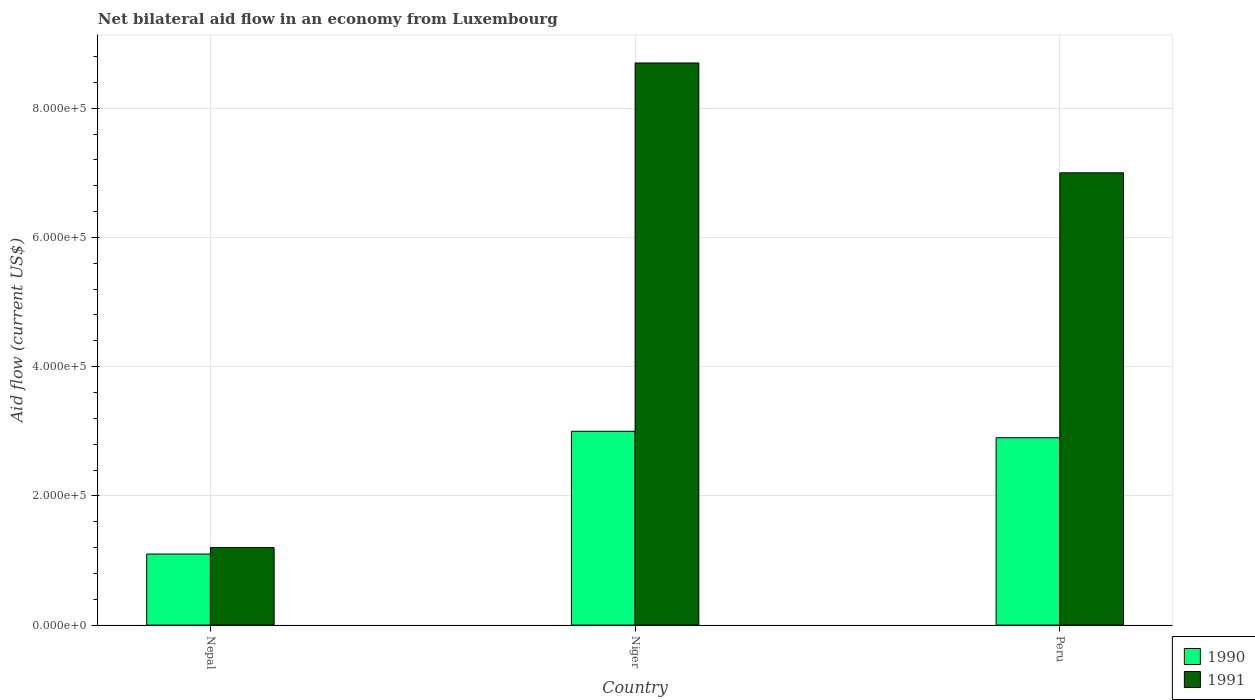How many groups of bars are there?
Offer a terse response. 3. Are the number of bars per tick equal to the number of legend labels?
Your answer should be compact. Yes. How many bars are there on the 2nd tick from the right?
Give a very brief answer. 2. What is the label of the 1st group of bars from the left?
Ensure brevity in your answer.  Nepal. In how many cases, is the number of bars for a given country not equal to the number of legend labels?
Provide a short and direct response. 0. What is the net bilateral aid flow in 1990 in Niger?
Ensure brevity in your answer.  3.00e+05. Across all countries, what is the maximum net bilateral aid flow in 1991?
Provide a short and direct response. 8.70e+05. Across all countries, what is the minimum net bilateral aid flow in 1991?
Give a very brief answer. 1.20e+05. In which country was the net bilateral aid flow in 1991 maximum?
Your answer should be compact. Niger. In which country was the net bilateral aid flow in 1990 minimum?
Provide a succinct answer. Nepal. What is the total net bilateral aid flow in 1991 in the graph?
Ensure brevity in your answer.  1.69e+06. What is the difference between the net bilateral aid flow in 1991 in Nepal and that in Niger?
Your response must be concise. -7.50e+05. What is the difference between the net bilateral aid flow in 1990 in Niger and the net bilateral aid flow in 1991 in Peru?
Offer a terse response. -4.00e+05. What is the average net bilateral aid flow in 1991 per country?
Ensure brevity in your answer.  5.63e+05. What is the difference between the net bilateral aid flow of/in 1991 and net bilateral aid flow of/in 1990 in Nepal?
Provide a short and direct response. 10000. In how many countries, is the net bilateral aid flow in 1991 greater than 440000 US$?
Ensure brevity in your answer.  2. What is the ratio of the net bilateral aid flow in 1990 in Nepal to that in Niger?
Keep it short and to the point. 0.37. Is the net bilateral aid flow in 1990 in Nepal less than that in Peru?
Your answer should be very brief. Yes. What is the difference between the highest and the second highest net bilateral aid flow in 1991?
Your answer should be compact. 1.70e+05. What is the difference between the highest and the lowest net bilateral aid flow in 1991?
Offer a very short reply. 7.50e+05. In how many countries, is the net bilateral aid flow in 1990 greater than the average net bilateral aid flow in 1990 taken over all countries?
Offer a terse response. 2. Is the sum of the net bilateral aid flow in 1991 in Nepal and Niger greater than the maximum net bilateral aid flow in 1990 across all countries?
Provide a succinct answer. Yes. What does the 1st bar from the left in Niger represents?
Offer a terse response. 1990. What does the 1st bar from the right in Nepal represents?
Provide a succinct answer. 1991. Are all the bars in the graph horizontal?
Your answer should be very brief. No. Are the values on the major ticks of Y-axis written in scientific E-notation?
Give a very brief answer. Yes. Does the graph contain any zero values?
Keep it short and to the point. No. Does the graph contain grids?
Give a very brief answer. Yes. How many legend labels are there?
Your answer should be compact. 2. What is the title of the graph?
Provide a short and direct response. Net bilateral aid flow in an economy from Luxembourg. Does "1983" appear as one of the legend labels in the graph?
Provide a short and direct response. No. What is the label or title of the X-axis?
Ensure brevity in your answer.  Country. What is the Aid flow (current US$) of 1991 in Nepal?
Give a very brief answer. 1.20e+05. What is the Aid flow (current US$) of 1990 in Niger?
Your answer should be very brief. 3.00e+05. What is the Aid flow (current US$) of 1991 in Niger?
Give a very brief answer. 8.70e+05. What is the Aid flow (current US$) in 1991 in Peru?
Offer a terse response. 7.00e+05. Across all countries, what is the maximum Aid flow (current US$) in 1991?
Provide a succinct answer. 8.70e+05. Across all countries, what is the minimum Aid flow (current US$) in 1991?
Keep it short and to the point. 1.20e+05. What is the total Aid flow (current US$) in 1991 in the graph?
Keep it short and to the point. 1.69e+06. What is the difference between the Aid flow (current US$) in 1991 in Nepal and that in Niger?
Offer a very short reply. -7.50e+05. What is the difference between the Aid flow (current US$) in 1990 in Nepal and that in Peru?
Your answer should be very brief. -1.80e+05. What is the difference between the Aid flow (current US$) of 1991 in Nepal and that in Peru?
Keep it short and to the point. -5.80e+05. What is the difference between the Aid flow (current US$) in 1990 in Niger and that in Peru?
Make the answer very short. 10000. What is the difference between the Aid flow (current US$) of 1991 in Niger and that in Peru?
Your answer should be very brief. 1.70e+05. What is the difference between the Aid flow (current US$) in 1990 in Nepal and the Aid flow (current US$) in 1991 in Niger?
Ensure brevity in your answer.  -7.60e+05. What is the difference between the Aid flow (current US$) in 1990 in Nepal and the Aid flow (current US$) in 1991 in Peru?
Keep it short and to the point. -5.90e+05. What is the difference between the Aid flow (current US$) of 1990 in Niger and the Aid flow (current US$) of 1991 in Peru?
Give a very brief answer. -4.00e+05. What is the average Aid flow (current US$) in 1990 per country?
Give a very brief answer. 2.33e+05. What is the average Aid flow (current US$) in 1991 per country?
Provide a short and direct response. 5.63e+05. What is the difference between the Aid flow (current US$) of 1990 and Aid flow (current US$) of 1991 in Nepal?
Offer a very short reply. -10000. What is the difference between the Aid flow (current US$) in 1990 and Aid flow (current US$) in 1991 in Niger?
Your response must be concise. -5.70e+05. What is the difference between the Aid flow (current US$) in 1990 and Aid flow (current US$) in 1991 in Peru?
Give a very brief answer. -4.10e+05. What is the ratio of the Aid flow (current US$) of 1990 in Nepal to that in Niger?
Your answer should be very brief. 0.37. What is the ratio of the Aid flow (current US$) in 1991 in Nepal to that in Niger?
Make the answer very short. 0.14. What is the ratio of the Aid flow (current US$) in 1990 in Nepal to that in Peru?
Make the answer very short. 0.38. What is the ratio of the Aid flow (current US$) in 1991 in Nepal to that in Peru?
Provide a short and direct response. 0.17. What is the ratio of the Aid flow (current US$) in 1990 in Niger to that in Peru?
Offer a very short reply. 1.03. What is the ratio of the Aid flow (current US$) in 1991 in Niger to that in Peru?
Offer a terse response. 1.24. What is the difference between the highest and the second highest Aid flow (current US$) in 1990?
Ensure brevity in your answer.  10000. What is the difference between the highest and the lowest Aid flow (current US$) in 1991?
Your answer should be very brief. 7.50e+05. 